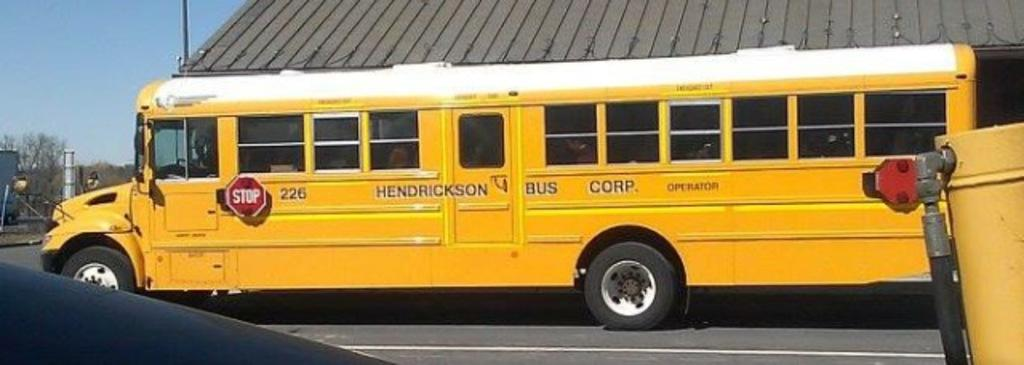Provide a one-sentence caption for the provided image. A yellow school bus from Henderson Bus Corp. 